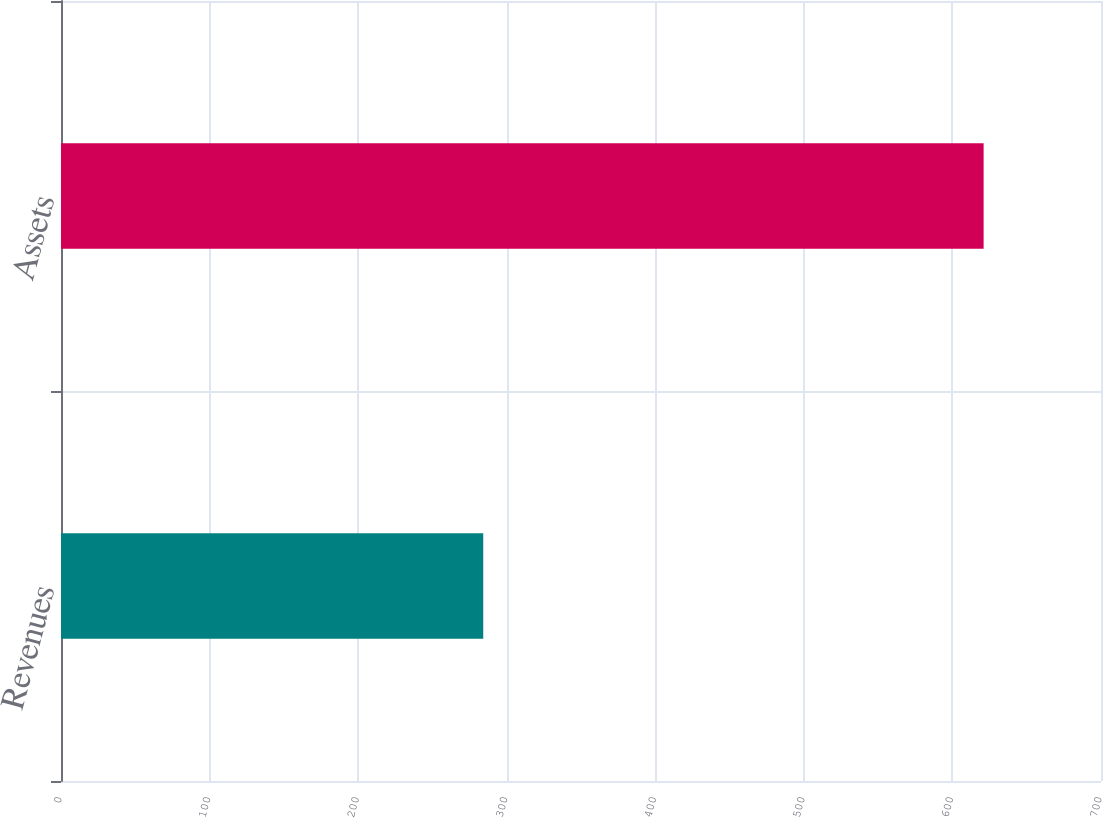<chart> <loc_0><loc_0><loc_500><loc_500><bar_chart><fcel>Revenues<fcel>Assets<nl><fcel>284.2<fcel>621<nl></chart> 